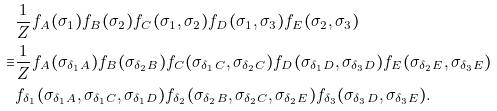Convert formula to latex. <formula><loc_0><loc_0><loc_500><loc_500>& \frac { 1 } { Z } f _ { A } ( \sigma _ { 1 } ) f _ { B } ( \sigma _ { 2 } ) f _ { C } ( \sigma _ { 1 } , \sigma _ { 2 } ) f _ { D } ( \sigma _ { 1 } , \sigma _ { 3 } ) f _ { E } ( \sigma _ { 2 } , \sigma _ { 3 } ) \\ \equiv & \frac { 1 } { Z } f _ { A } ( \sigma _ { \delta _ { 1 } A } ) f _ { B } ( \sigma _ { \delta _ { 2 } B } ) f _ { C } ( \sigma _ { \delta _ { 1 } C } , \sigma _ { \delta _ { 2 } C } ) f _ { D } ( \sigma _ { \delta _ { 1 } D } , \sigma _ { \delta _ { 3 } D } ) f _ { E } ( \sigma _ { \delta _ { 2 } E } , \sigma _ { \delta _ { 3 } E } ) \\ & f _ { \delta _ { 1 } } ( \sigma _ { \delta _ { 1 } A } , \sigma _ { \delta _ { 1 } C } , \sigma _ { \delta _ { 1 } D } ) f _ { \delta _ { 2 } } ( \sigma _ { \delta _ { 2 } B } , \sigma _ { \delta _ { 2 } C } , \sigma _ { \delta _ { 2 } E } ) f _ { \delta _ { 3 } } ( \sigma _ { \delta _ { 3 } D } , \sigma _ { \delta _ { 3 } E } ) .</formula> 